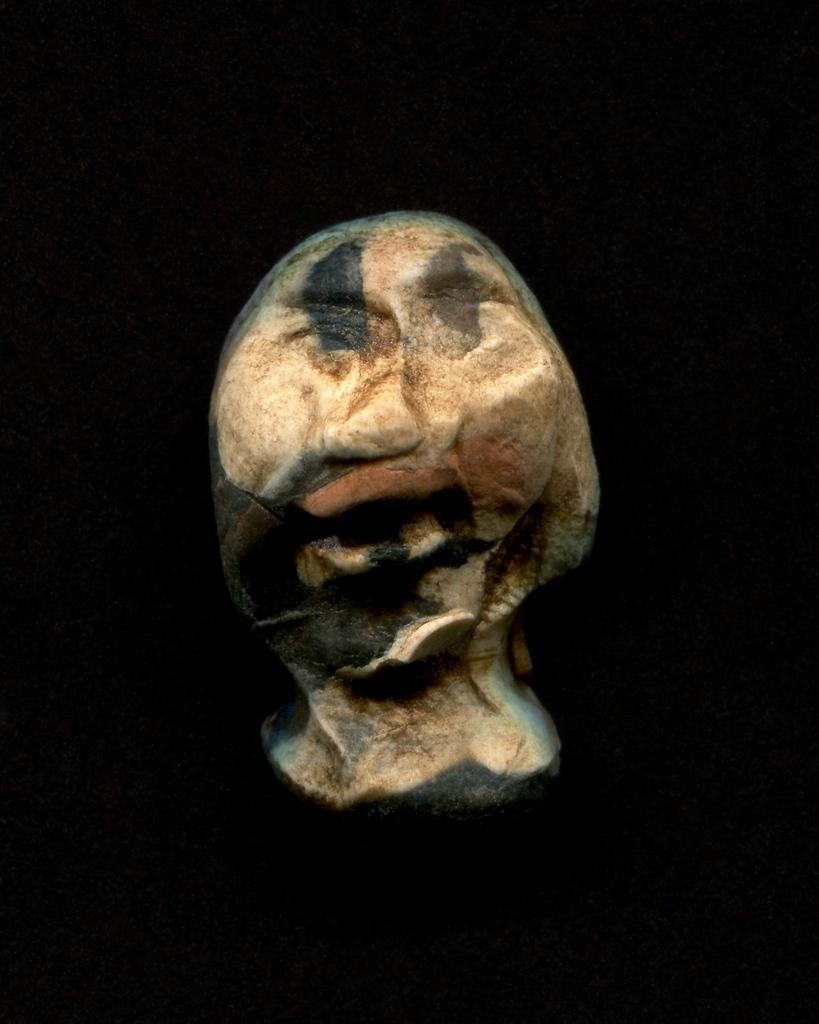What is the main subject of the image? There is a stone sculpture in the image. Can you describe the background of the image? The background of the image is dark. What type of weather can be seen in the image? There is no weather depicted in the image, as it only features a stone sculpture and a dark background. 